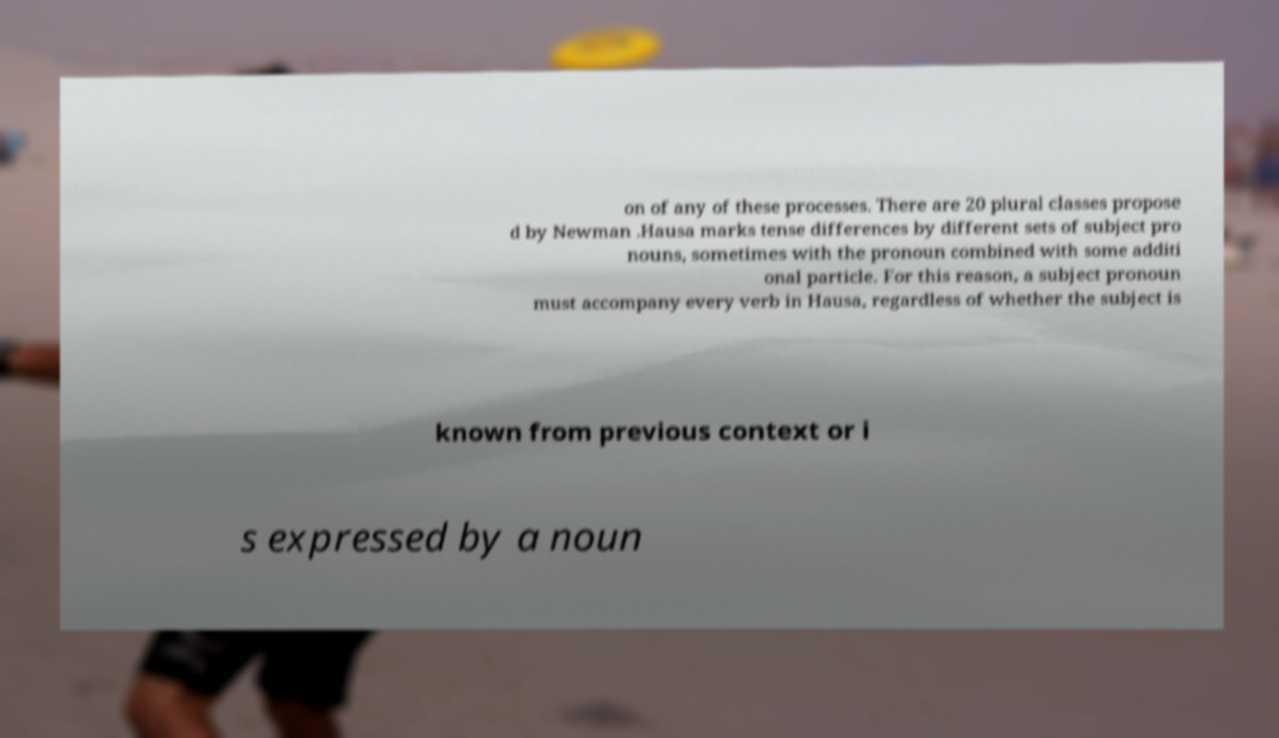Please read and relay the text visible in this image. What does it say? on of any of these processes. There are 20 plural classes propose d by Newman .Hausa marks tense differences by different sets of subject pro nouns, sometimes with the pronoun combined with some additi onal particle. For this reason, a subject pronoun must accompany every verb in Hausa, regardless of whether the subject is known from previous context or i s expressed by a noun 